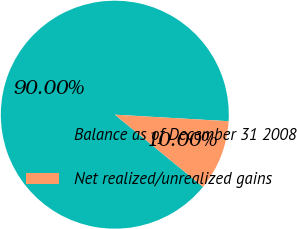Convert chart. <chart><loc_0><loc_0><loc_500><loc_500><pie_chart><fcel>Balance as of December 31 2008<fcel>Net realized/unrealized gains<nl><fcel>90.0%<fcel>10.0%<nl></chart> 